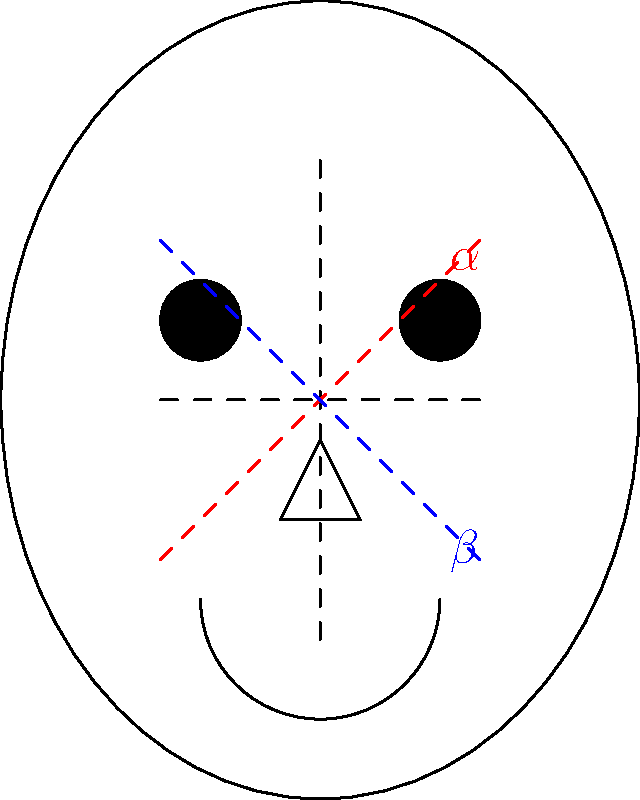In the facial diagram above, two angles ($\alpha$ and $\beta$) are formed by the intersection of diagonal lines with the vertical axis. Research suggests that the ratio of these angles ($\frac{\alpha}{\beta}$) correlates with perceived personality traits. If $\alpha = 60°$ and the ratio $\frac{\alpha}{\beta} = 1.2$, what is the value of $\beta$, and what might this suggest about the perceived personality of the individual? To solve this problem, we'll follow these steps:

1) We're given that $\alpha = 60°$ and $\frac{\alpha}{\beta} = 1.2$

2) Let's express this ratio as an equation:
   $\frac{60°}{\beta} = 1.2$

3) To solve for $\beta$, we can cross-multiply:
   $60° = 1.2\beta$

4) Now, divide both sides by 1.2:
   $\frac{60°}{1.2} = \beta$

5) Calculate the result:
   $\beta = 50°$

6) Interpretation of the result:
   - A ratio of 1.2 indicates that the upper angle ($\alpha$) is slightly larger than the lower angle ($\beta$).
   - In facial perception research, a larger upper angle is often associated with traits like openness and approachability.
   - The relatively small difference (60° vs 50°) suggests a balanced facial structure.
   - This could be interpreted as indicating a personality that is perceived as approachable and open, but also grounded and stable.
   - However, it's crucial to note that these interpretations are based on general trends in perception studies and should not be considered definitive or deterministic.
Answer: $\beta = 50°$; suggests perceived approachability with stability 